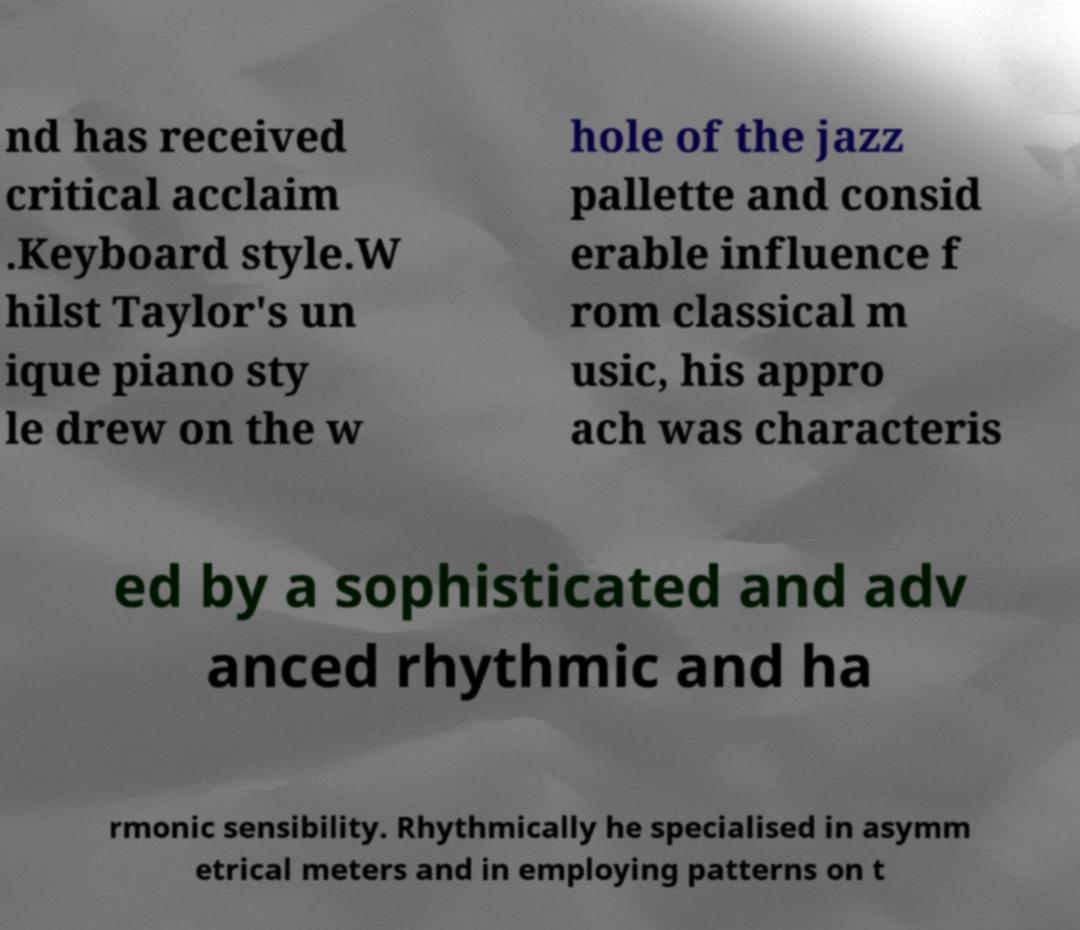There's text embedded in this image that I need extracted. Can you transcribe it verbatim? nd has received critical acclaim .Keyboard style.W hilst Taylor's un ique piano sty le drew on the w hole of the jazz pallette and consid erable influence f rom classical m usic, his appro ach was characteris ed by a sophisticated and adv anced rhythmic and ha rmonic sensibility. Rhythmically he specialised in asymm etrical meters and in employing patterns on t 